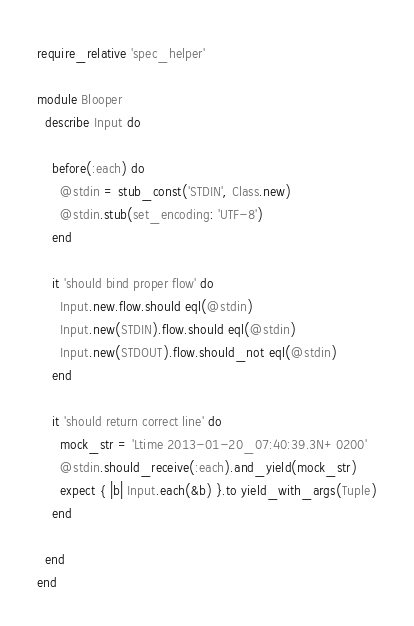Convert code to text. <code><loc_0><loc_0><loc_500><loc_500><_Ruby_>require_relative 'spec_helper'

module Blooper
  describe Input do

    before(:each) do
      @stdin = stub_const('STDIN', Class.new)
      @stdin.stub(set_encoding: 'UTF-8')
    end

    it 'should bind proper flow' do
      Input.new.flow.should eql(@stdin)
      Input.new(STDIN).flow.should eql(@stdin)
      Input.new(STDOUT).flow.should_not eql(@stdin)
    end

    it 'should return correct line' do
      mock_str = 'Ltime 2013-01-20_07:40:39.3N+0200'
      @stdin.should_receive(:each).and_yield(mock_str)
      expect { |b| Input.each(&b) }.to yield_with_args(Tuple)
    end

  end
end
</code> 